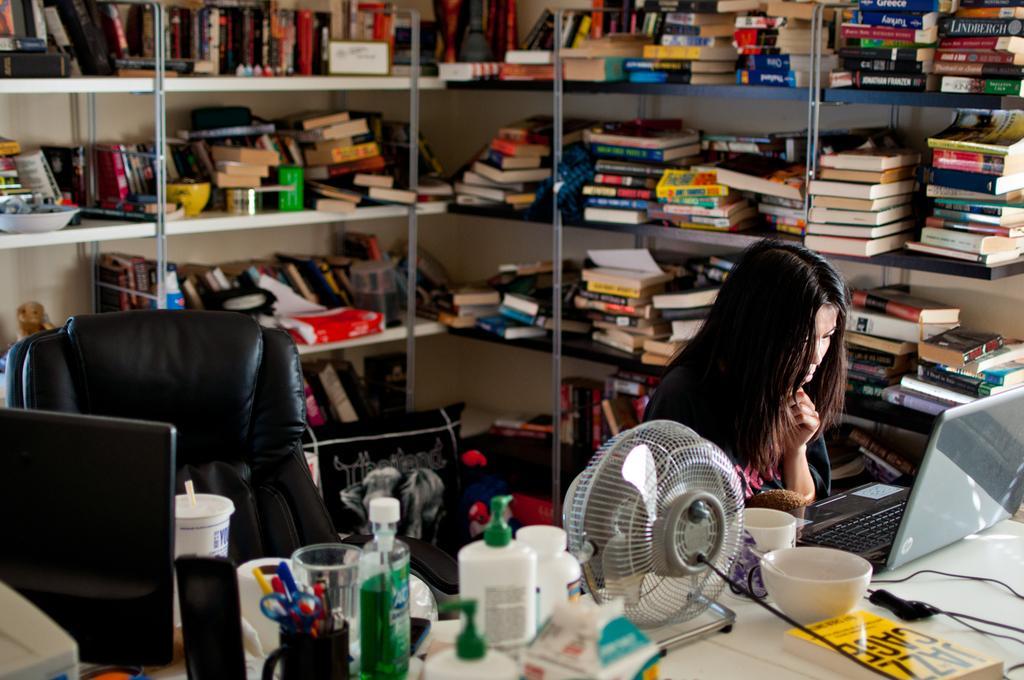How would you summarize this image in a sentence or two? This is a room consist of racks and on the racks number of books kept on the rack and there is a chair and there is a table ,on the table there are number of objects kept on the table and in front of the table there is a woman sitting on the chair. 